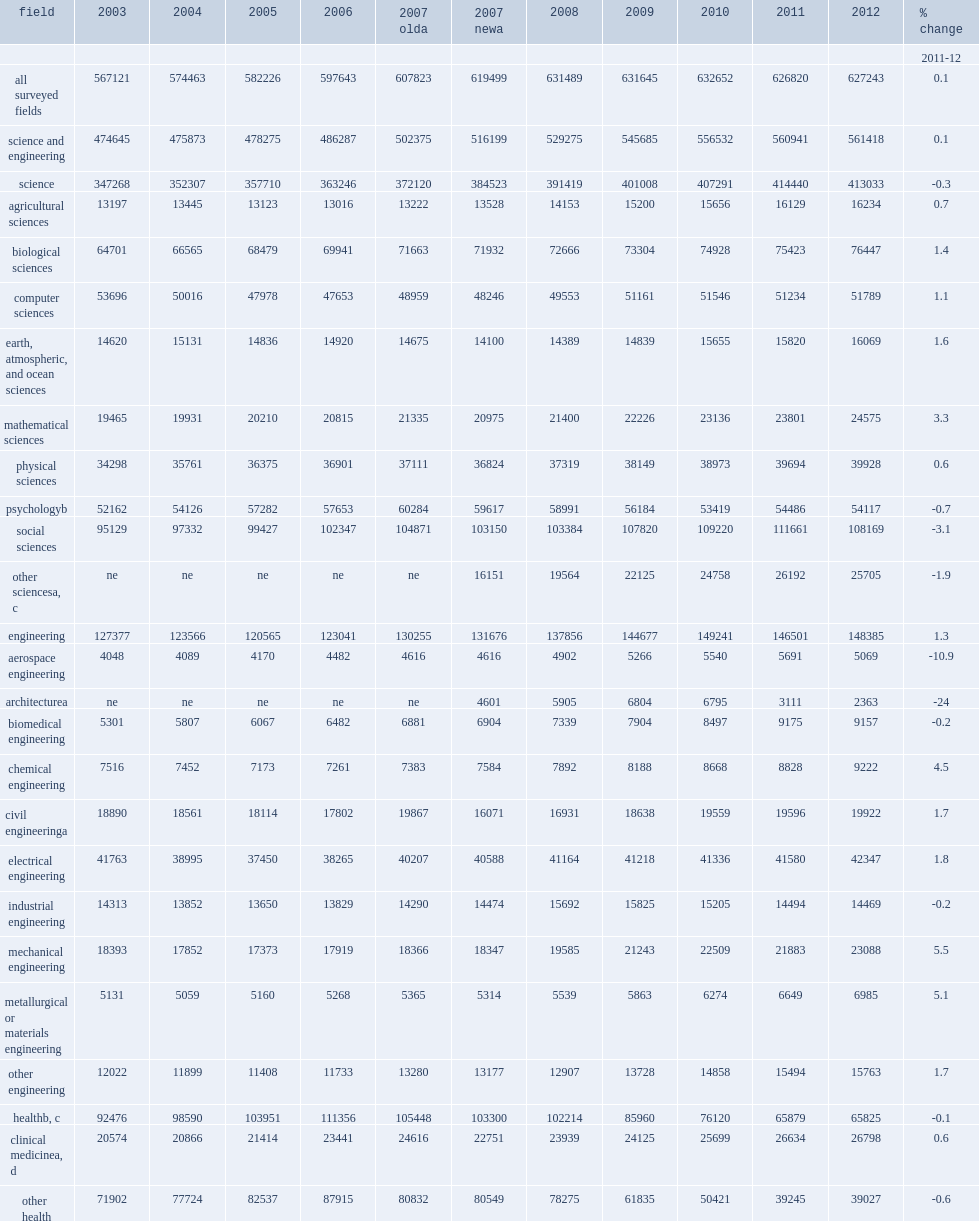Give me the full table as a dictionary. {'header': ['field', '2003', '2004', '2005', '2006', '2007 olda', '2007 newa', '2008', '2009', '2010', '2011', '2012', '% change'], 'rows': [['', '', '', '', '', '', '', '', '', '', '', '', '2011-12'], ['all surveyed fields', '567121', '574463', '582226', '597643', '607823', '619499', '631489', '631645', '632652', '626820', '627243', '0.1'], ['science and engineering', '474645', '475873', '478275', '486287', '502375', '516199', '529275', '545685', '556532', '560941', '561418', '0.1'], ['science', '347268', '352307', '357710', '363246', '372120', '384523', '391419', '401008', '407291', '414440', '413033', '-0.3'], ['agricultural sciences', '13197', '13445', '13123', '13016', '13222', '13528', '14153', '15200', '15656', '16129', '16234', '0.7'], ['biological sciences', '64701', '66565', '68479', '69941', '71663', '71932', '72666', '73304', '74928', '75423', '76447', '1.4'], ['computer sciences', '53696', '50016', '47978', '47653', '48959', '48246', '49553', '51161', '51546', '51234', '51789', '1.1'], ['earth, atmospheric, and ocean sciences', '14620', '15131', '14836', '14920', '14675', '14100', '14389', '14839', '15655', '15820', '16069', '1.6'], ['mathematical sciences', '19465', '19931', '20210', '20815', '21335', '20975', '21400', '22226', '23136', '23801', '24575', '3.3'], ['physical sciences', '34298', '35761', '36375', '36901', '37111', '36824', '37319', '38149', '38973', '39694', '39928', '0.6'], ['psychologyb', '52162', '54126', '57282', '57653', '60284', '59617', '58991', '56184', '53419', '54486', '54117', '-0.7'], ['social sciences', '95129', '97332', '99427', '102347', '104871', '103150', '103384', '107820', '109220', '111661', '108169', '-3.1'], ['other sciencesa, c', 'ne', 'ne', 'ne', 'ne', 'ne', '16151', '19564', '22125', '24758', '26192', '25705', '-1.9'], ['engineering', '127377', '123566', '120565', '123041', '130255', '131676', '137856', '144677', '149241', '146501', '148385', '1.3'], ['aerospace engineering', '4048', '4089', '4170', '4482', '4616', '4616', '4902', '5266', '5540', '5691', '5069', '-10.9'], ['architecturea', 'ne', 'ne', 'ne', 'ne', 'ne', '4601', '5905', '6804', '6795', '3111', '2363', '-24'], ['biomedical engineering', '5301', '5807', '6067', '6482', '6881', '6904', '7339', '7904', '8497', '9175', '9157', '-0.2'], ['chemical engineering', '7516', '7452', '7173', '7261', '7383', '7584', '7892', '8188', '8668', '8828', '9222', '4.5'], ['civil engineeringa', '18890', '18561', '18114', '17802', '19867', '16071', '16931', '18638', '19559', '19596', '19922', '1.7'], ['electrical engineering', '41763', '38995', '37450', '38265', '40207', '40588', '41164', '41218', '41336', '41580', '42347', '1.8'], ['industrial engineering', '14313', '13852', '13650', '13829', '14290', '14474', '15692', '15825', '15205', '14494', '14469', '-0.2'], ['mechanical engineering', '18393', '17852', '17373', '17919', '18366', '18347', '19585', '21243', '22509', '21883', '23088', '5.5'], ['metallurgical or materials engineering', '5131', '5059', '5160', '5268', '5365', '5314', '5539', '5863', '6274', '6649', '6985', '5.1'], ['other engineering', '12022', '11899', '11408', '11733', '13280', '13177', '12907', '13728', '14858', '15494', '15763', '1.7'], ['healthb, c', '92476', '98590', '103951', '111356', '105448', '103300', '102214', '85960', '76120', '65879', '65825', '-0.1'], ['clinical medicinea, d', '20574', '20866', '21414', '23441', '24616', '22751', '23939', '24125', '25699', '26634', '26798', '0.6'], ['other health', '71902', '77724', '82537', '87915', '80832', '80549', '78275', '61835', '50421', '39245', '39027', '-0.6']]} After a decade of steady growth, how many percent of the number of graduate students enrolled in science fields decrease overall by between 2011 and 2012? 0.3. 